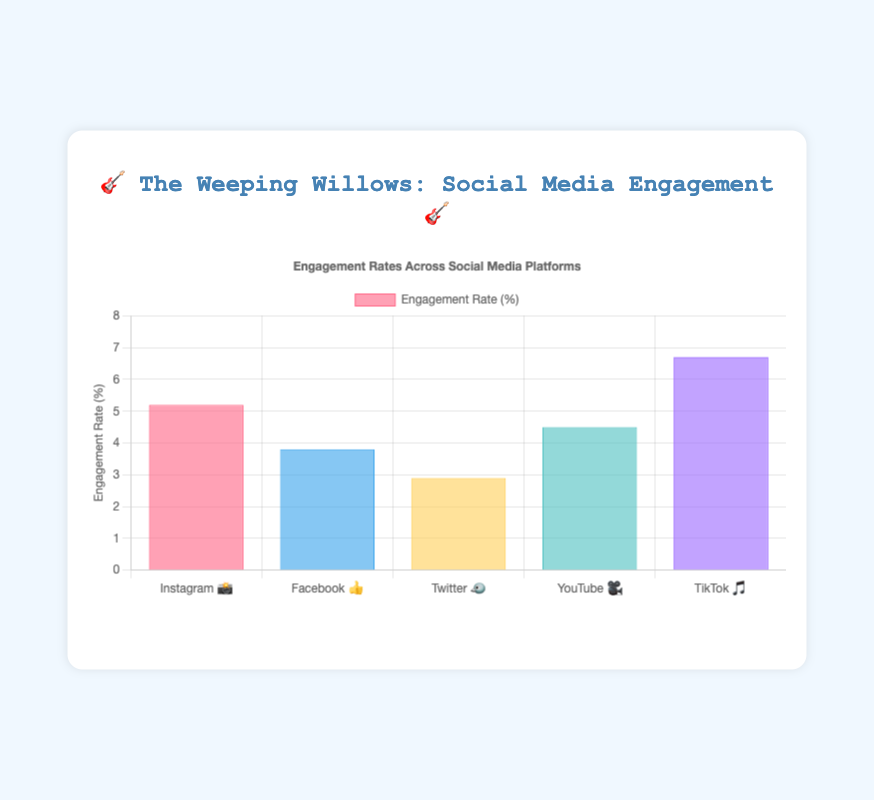What's the highest engagement rate among the social media platforms? Look at the bars on the chart and identify the one with the tallest height. TikTok 🎵 has the highest engagement rate of 6.7%.
Answer: 6.7% Which platform has the lowest engagement rate? Look at the bars on the chart and identify the shortest one. Twitter 🐦 has the lowest engagement rate of 2.9%.
Answer: 2.9% How many posts were made on Instagram 📸? Refer to the data provided, which shows the number of posts for Instagram is 78.
Answer: 78 What is the total number of posts across all platforms? Add all the posts together: 78 (Instagram) + 65 (Facebook) + 120 (Twitter) + 25 (YouTube) + 40 (TikTok) = 328 posts.
Answer: 328 What is the average engagement rate across all platforms? Calculate the average by summing all engagement rates and dividing by the number of platforms: (5.2 + 3.8 + 2.9 + 4.5 + 6.7) / 5 = 4.62%.
Answer: 4.62% Which platform has a higher engagement rate, YouTube 🎥 or Facebook 👍? Compare the engagement rates of YouTube (4.5%) and Facebook (3.8%). YouTube's rate is higher.
Answer: YouTube 🎥 Which platform posted the most, considering the number of posts? Find the platform with the highest number of posts. Twitter 🐦 has the most posts with 120.
Answer: Twitter 🐦 What is the difference in engagement rates between the highest and the lowest platform? Subtract the lowest engagement rate (Twitter 🐦, 2.9%) from the highest (TikTok 🎵, 6.7%): 6.7 - 2.9 = 3.8%.
Answer: 3.8% On which platforms is the engagement rate more than 5%? Check each platform and list those whose engagement rate exceeds 5%. Instagram 📸 (5.2%) and TikTok 🎵 (6.7%) have rates over 5%.
Answer: Instagram 📸, TikTok 🎵 What is the engagement rate range of the platforms? Find the difference between the highest and lowest engagement rates: 6.7% (TikTok) - 2.9% (Twitter) = 3.8%.
Answer: 3.8% 